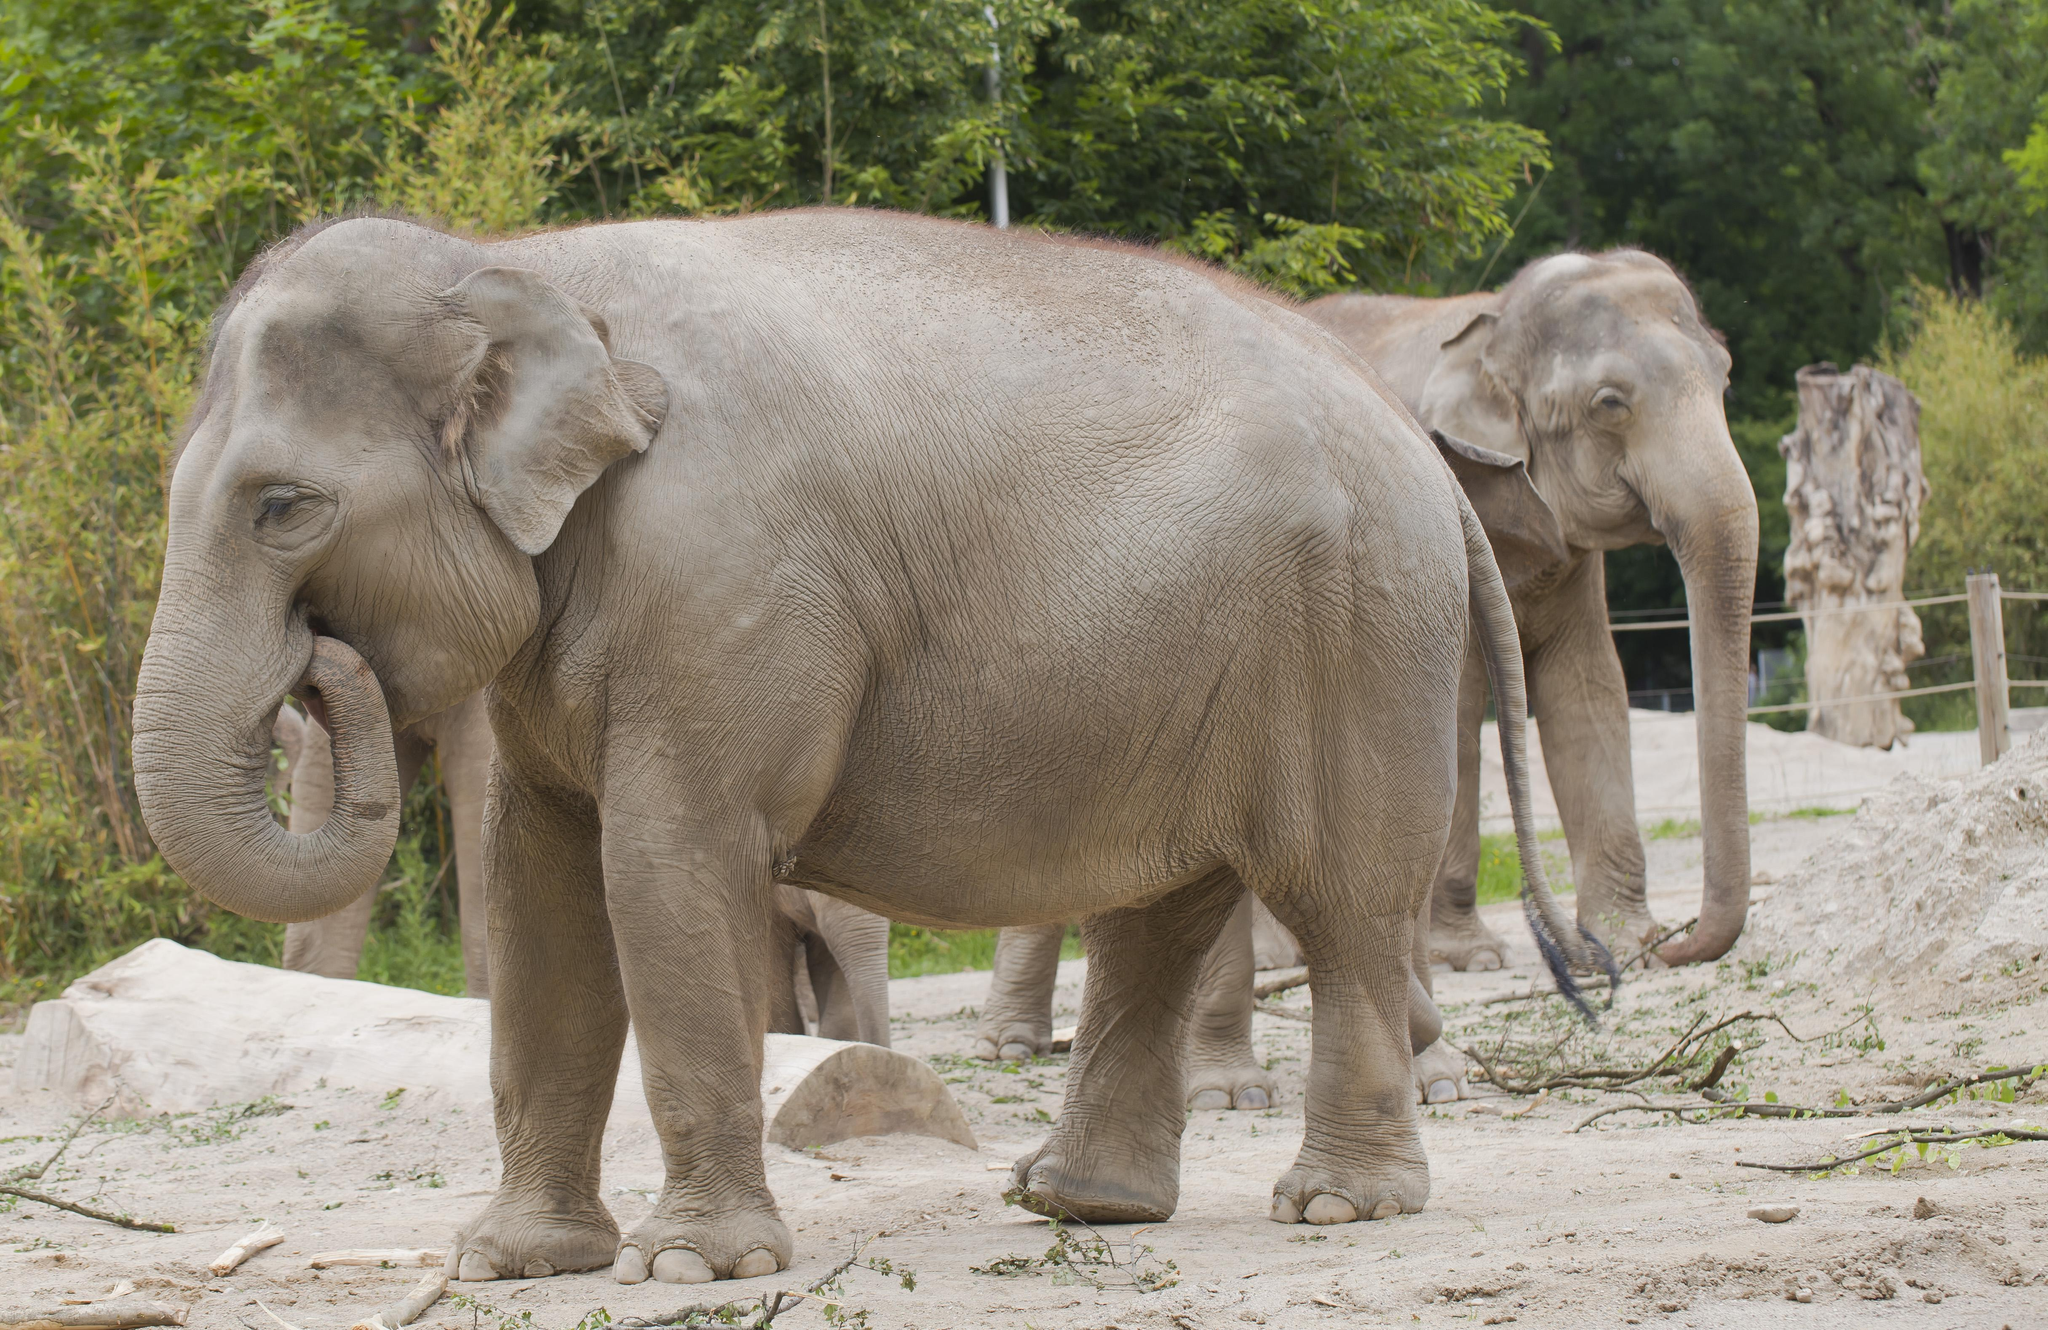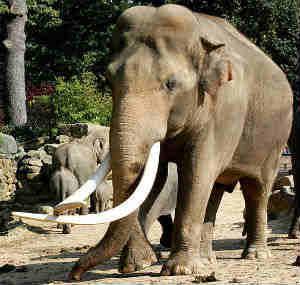The first image is the image on the left, the second image is the image on the right. Evaluate the accuracy of this statement regarding the images: "An image includes exactly one elephant, which has an upraised, curled trunk.". Is it true? Answer yes or no. No. 